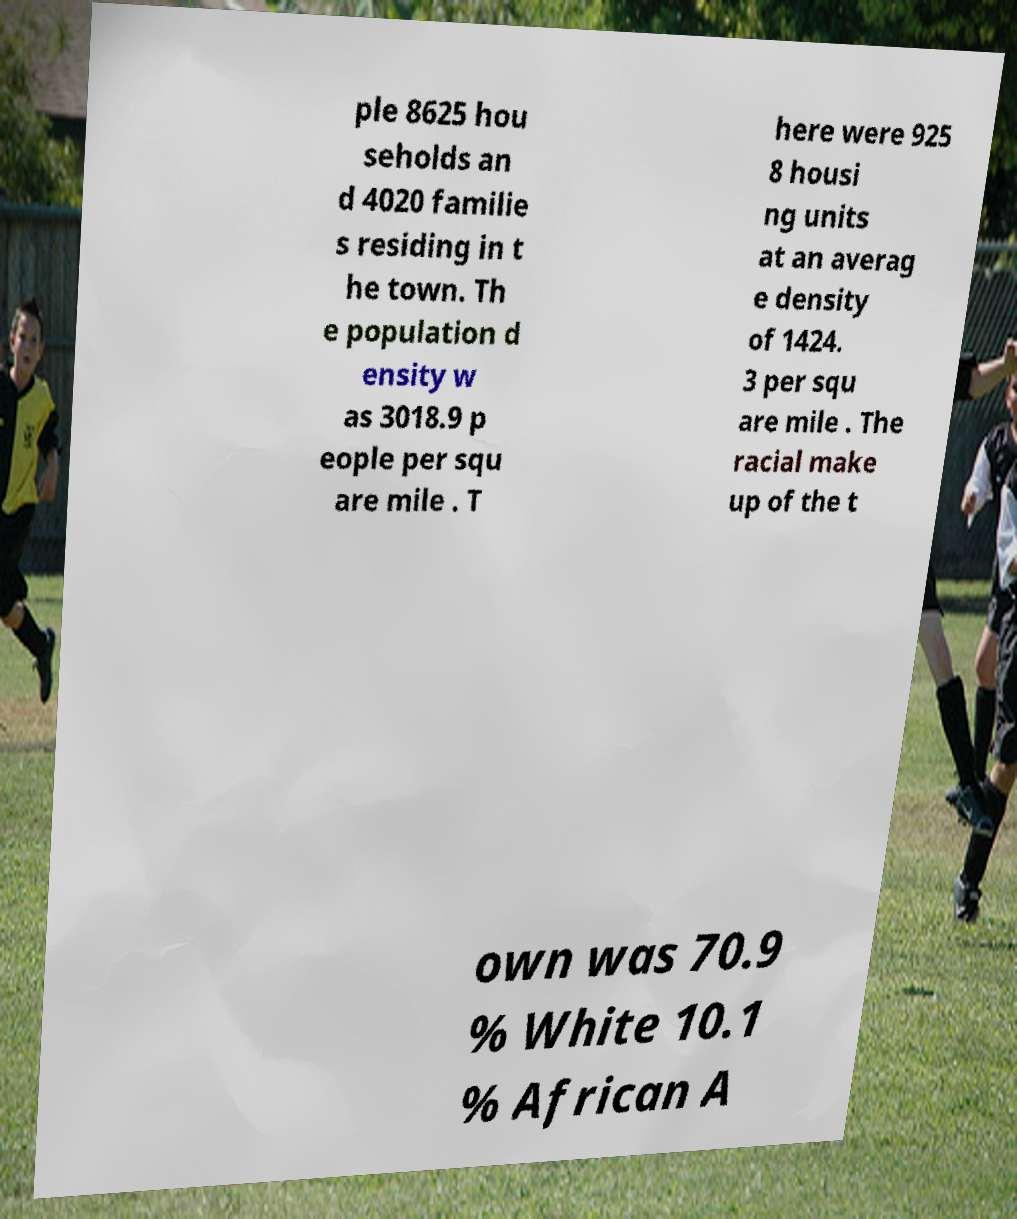Can you read and provide the text displayed in the image?This photo seems to have some interesting text. Can you extract and type it out for me? ple 8625 hou seholds an d 4020 familie s residing in t he town. Th e population d ensity w as 3018.9 p eople per squ are mile . T here were 925 8 housi ng units at an averag e density of 1424. 3 per squ are mile . The racial make up of the t own was 70.9 % White 10.1 % African A 